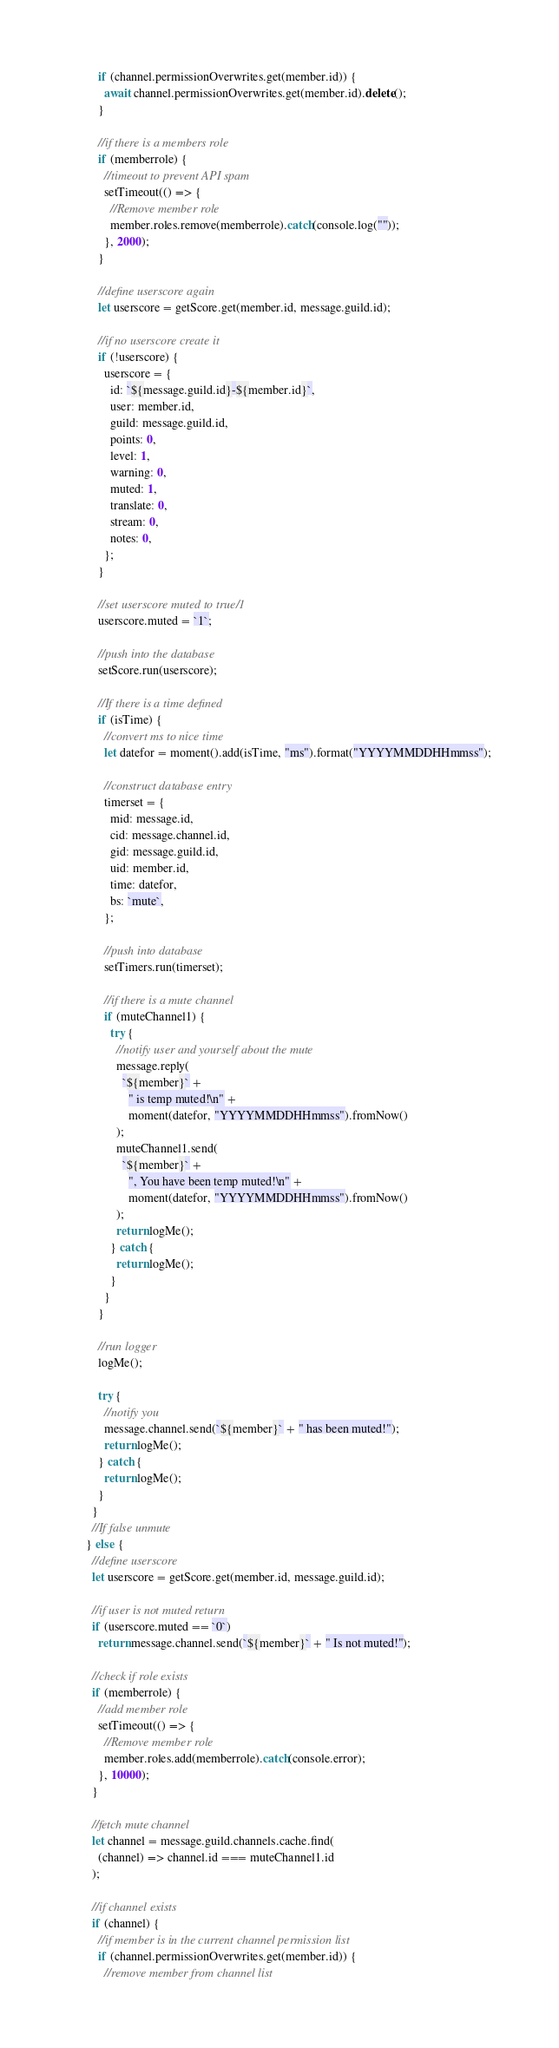<code> <loc_0><loc_0><loc_500><loc_500><_JavaScript_>          if (channel.permissionOverwrites.get(member.id)) {
            await channel.permissionOverwrites.get(member.id).delete();
          }

          //if there is a members role
          if (memberrole) {
            //timeout to prevent API spam
            setTimeout(() => {
              //Remove member role
              member.roles.remove(memberrole).catch(console.log(""));
            }, 2000);
          }

          //define userscore again
          let userscore = getScore.get(member.id, message.guild.id);

          //if no userscore create it
          if (!userscore) {
            userscore = {
              id: `${message.guild.id}-${member.id}`,
              user: member.id,
              guild: message.guild.id,
              points: 0,
              level: 1,
              warning: 0,
              muted: 1,
              translate: 0,
              stream: 0,
              notes: 0,
            };
          }

          //set userscore muted to true/1
          userscore.muted = `1`;

          //push into the database
          setScore.run(userscore);

          //If there is a time defined
          if (isTime) {
            //convert ms to nice time
            let datefor = moment().add(isTime, "ms").format("YYYYMMDDHHmmss");

            //construct database entry
            timerset = {
              mid: message.id,
              cid: message.channel.id,
              gid: message.guild.id,
              uid: member.id,
              time: datefor,
              bs: `mute`,
            };

            //push into database
            setTimers.run(timerset);

            //if there is a mute channel
            if (muteChannel1) {
              try {
                //notify user and yourself about the mute
                message.reply(
                  `${member}` +
                    " is temp muted!\n" +
                    moment(datefor, "YYYYMMDDHHmmss").fromNow()
                );
                muteChannel1.send(
                  `${member}` +
                    ", You have been temp muted!\n" +
                    moment(datefor, "YYYYMMDDHHmmss").fromNow()
                );
                return logMe();
              } catch {
                return logMe();
              }
            }
          }

          //run logger
          logMe();

          try {
            //notify you
            message.channel.send(`${member}` + " has been muted!");
            return logMe();
          } catch {
            return logMe();
          }
        }
        //If false unmute
      } else {
        //define userscore
        let userscore = getScore.get(member.id, message.guild.id);

        //if user is not muted return
        if (userscore.muted == `0`)
          return message.channel.send(`${member}` + " Is not muted!");

        //check if role exists
        if (memberrole) {
          //add member role
          setTimeout(() => {
            //Remove member role
            member.roles.add(memberrole).catch(console.error);
          }, 10000);
        }

        //fetch mute channel
        let channel = message.guild.channels.cache.find(
          (channel) => channel.id === muteChannel1.id
        );

        //if channel exists
        if (channel) {
          //if member is in the current channel permission list
          if (channel.permissionOverwrites.get(member.id)) {
            //remove member from channel list</code> 